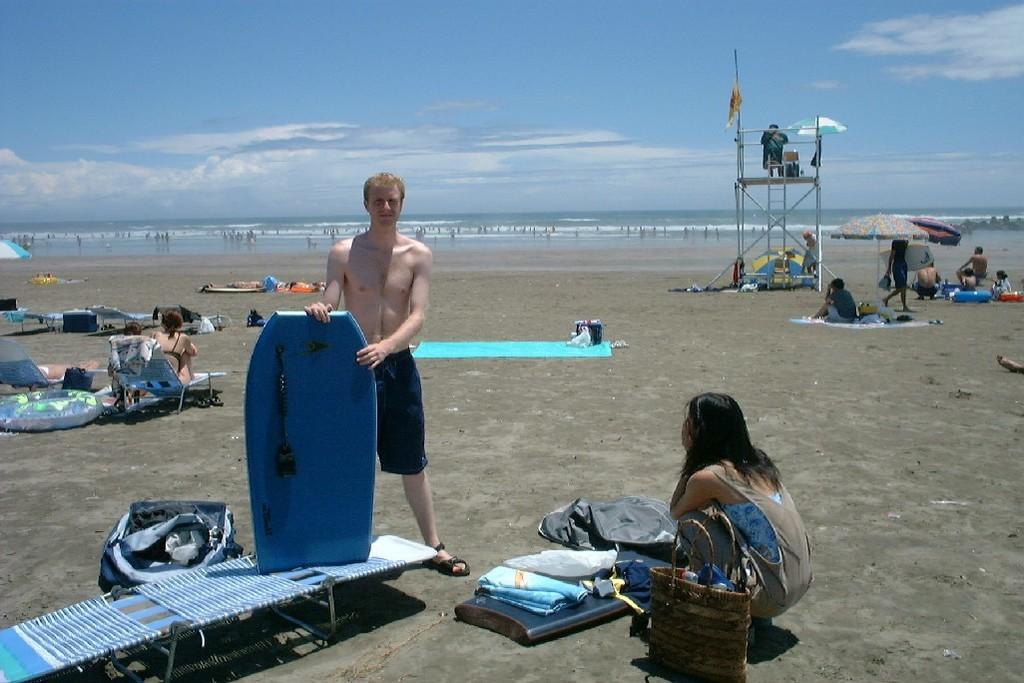Can you describe this image briefly? In this image I see a man who is standing and he is with the ski board and I see a woman over here and I see a bag, In the background number of people who are sitting and lying on the mat. I can also see the sand, water and the sky. 